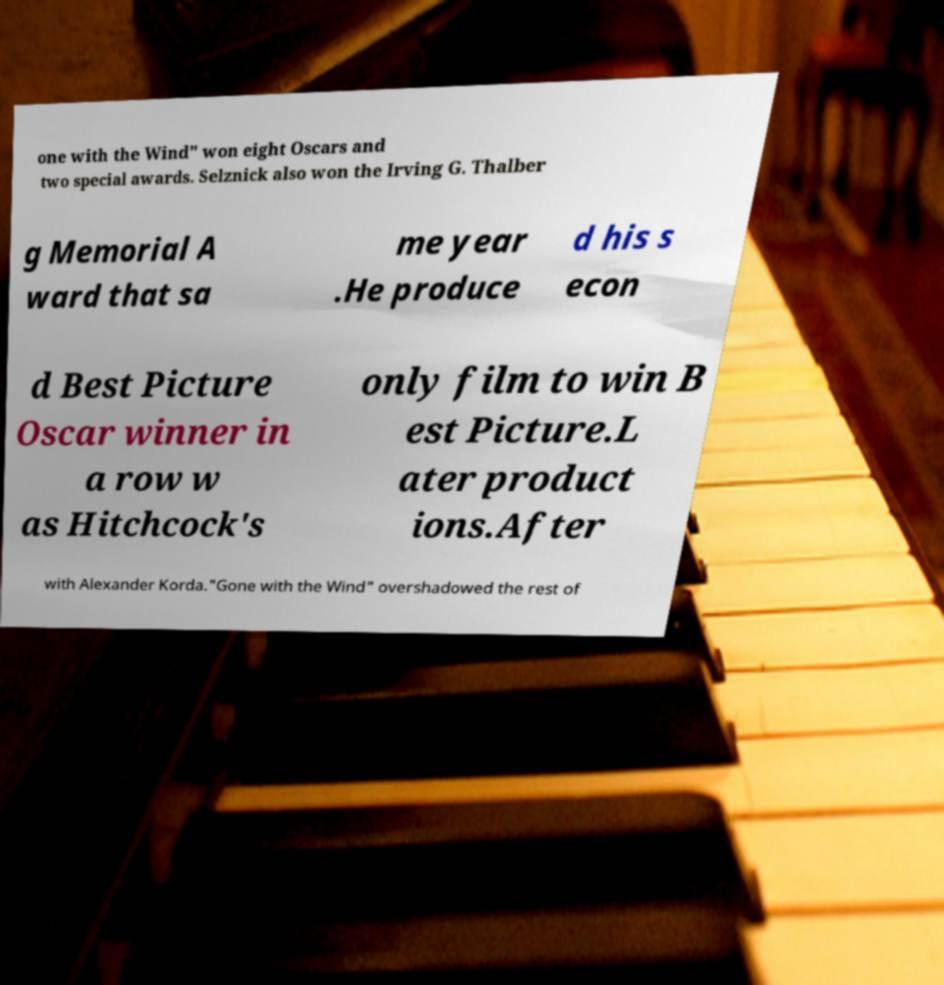Can you accurately transcribe the text from the provided image for me? one with the Wind" won eight Oscars and two special awards. Selznick also won the Irving G. Thalber g Memorial A ward that sa me year .He produce d his s econ d Best Picture Oscar winner in a row w as Hitchcock's only film to win B est Picture.L ater product ions.After with Alexander Korda."Gone with the Wind" overshadowed the rest of 